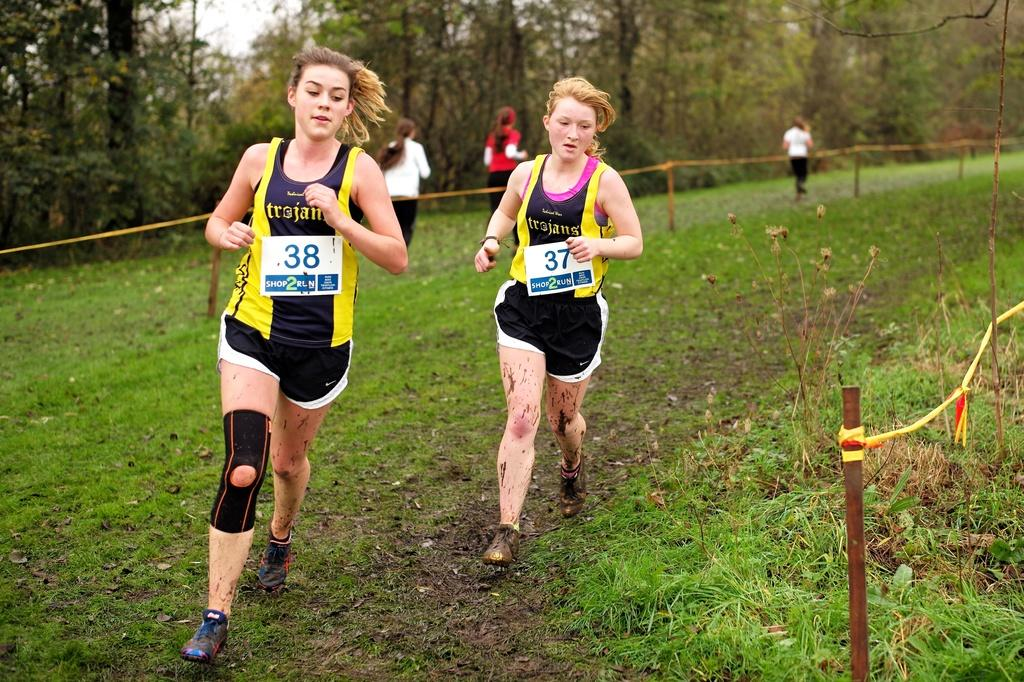What are the people in the image doing? The people in the image are walking on the grass. What can be seen on the sides of the image? Fencing is present on both the right and left sides of the image. What is visible in the background of the image? There are trees visible in the background of the image. How many cats can be seen playing with the sun in the image? There are no cats or sun present in the image. What type of plants are growing on the people walking in the image? There are no plants growing on the people walking in the image. 